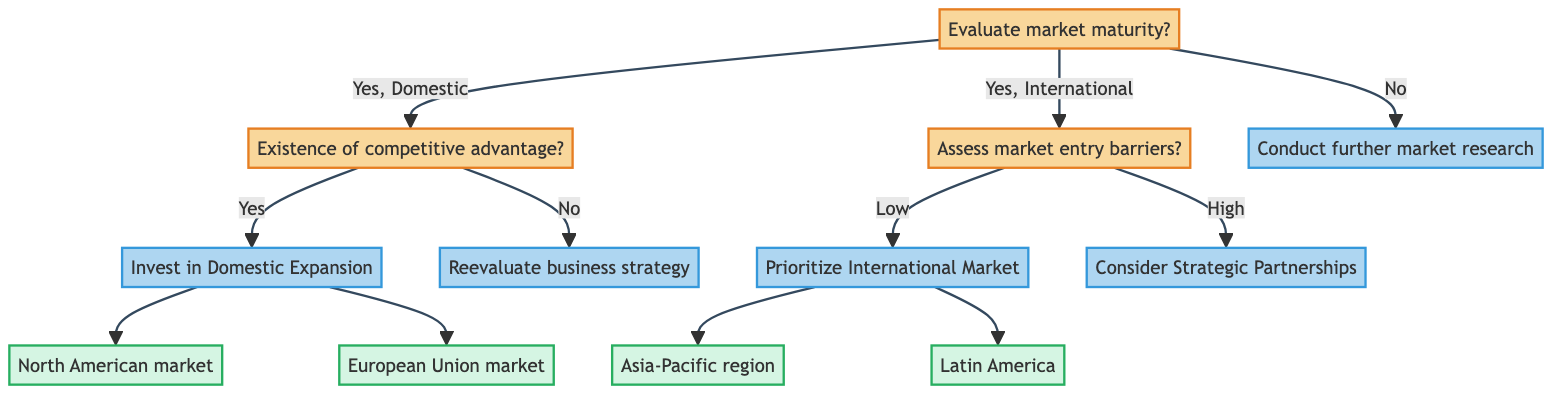What is the first question in the decision tree? The first question is "Evaluate market maturity?" as it is positioned at the start of the decision-making process in the diagram.
Answer: Evaluate market maturity? How many entities are listed under "Invest in Domestic Expansion"? There are two entities listed under "Invest in Domestic Expansion," which are "North American market" and "European Union market."
Answer: 2 What decision follows a "No" answer to the "Evaluate market maturity?" question? The decision that follows a "No" answer is "Conduct further market research," indicating the need for additional analysis when market maturity is not evaluated as mature.
Answer: Conduct further market research If "Assess market entry barriers?" receives a "High" response, what decision is made? A "High" response to the "Assess market entry barriers?" question leads to the decision "Consider Strategic Partnerships," suggesting alternative strategies to tackle high barriers.
Answer: Consider Strategic Partnerships What are the two entities to prioritize if market entry barriers are assessed as low? If the market entry barriers are assessed as low, the two entities to prioritize are "Asia-Pacific region" and "Latin America," indicating favorable markets for expansion.
Answer: Asia-Pacific region, Latin America What action is taken if there is no competitive advantage? If there is no competitive advantage, the action to be taken is "Reevaluate business strategy," which implies a reassessment of the current strategies.
Answer: Reevaluate business strategy What is the link between assessing market entry barriers and the "Prioritize International Market" decision? Assessing market entry barriers determines whether to prioritize international expansion, with a "Low" response leading directly to the "Prioritize International Market" decision.
Answer: Low What is the decision made after confirming existence of competitive advantage? The decision made after confirming existence of competitive advantage is "Invest in Domestic Expansion," suggesting a focus on growth within the domestic market.
Answer: Invest in Domestic Expansion 